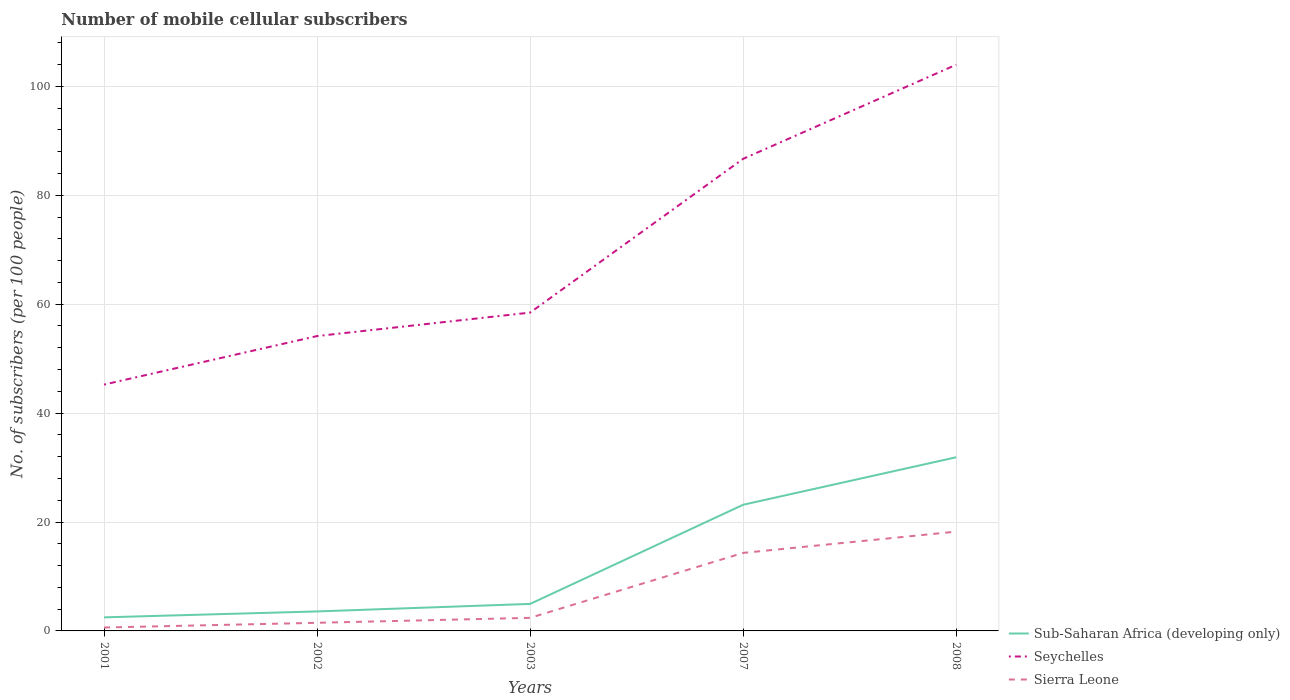How many different coloured lines are there?
Offer a very short reply. 3. Does the line corresponding to Sierra Leone intersect with the line corresponding to Sub-Saharan Africa (developing only)?
Your answer should be very brief. No. Is the number of lines equal to the number of legend labels?
Your answer should be compact. Yes. Across all years, what is the maximum number of mobile cellular subscribers in Sierra Leone?
Your response must be concise. 0.63. In which year was the number of mobile cellular subscribers in Sierra Leone maximum?
Your answer should be compact. 2001. What is the total number of mobile cellular subscribers in Sierra Leone in the graph?
Offer a terse response. -15.83. What is the difference between the highest and the second highest number of mobile cellular subscribers in Sierra Leone?
Provide a short and direct response. 17.61. What is the difference between the highest and the lowest number of mobile cellular subscribers in Seychelles?
Provide a short and direct response. 2. How many lines are there?
Your answer should be very brief. 3. Does the graph contain any zero values?
Provide a succinct answer. No. Does the graph contain grids?
Ensure brevity in your answer.  Yes. Where does the legend appear in the graph?
Offer a terse response. Bottom right. What is the title of the graph?
Keep it short and to the point. Number of mobile cellular subscribers. What is the label or title of the X-axis?
Give a very brief answer. Years. What is the label or title of the Y-axis?
Your answer should be very brief. No. of subscribers (per 100 people). What is the No. of subscribers (per 100 people) in Sub-Saharan Africa (developing only) in 2001?
Make the answer very short. 2.49. What is the No. of subscribers (per 100 people) in Seychelles in 2001?
Provide a succinct answer. 45.24. What is the No. of subscribers (per 100 people) in Sierra Leone in 2001?
Keep it short and to the point. 0.63. What is the No. of subscribers (per 100 people) of Sub-Saharan Africa (developing only) in 2002?
Provide a short and direct response. 3.58. What is the No. of subscribers (per 100 people) in Seychelles in 2002?
Give a very brief answer. 54.15. What is the No. of subscribers (per 100 people) of Sierra Leone in 2002?
Your answer should be compact. 1.49. What is the No. of subscribers (per 100 people) of Sub-Saharan Africa (developing only) in 2003?
Offer a terse response. 4.96. What is the No. of subscribers (per 100 people) of Seychelles in 2003?
Your response must be concise. 58.45. What is the No. of subscribers (per 100 people) of Sierra Leone in 2003?
Offer a very short reply. 2.4. What is the No. of subscribers (per 100 people) of Sub-Saharan Africa (developing only) in 2007?
Your answer should be compact. 23.17. What is the No. of subscribers (per 100 people) of Seychelles in 2007?
Your response must be concise. 86.7. What is the No. of subscribers (per 100 people) in Sierra Leone in 2007?
Keep it short and to the point. 14.33. What is the No. of subscribers (per 100 people) in Sub-Saharan Africa (developing only) in 2008?
Provide a succinct answer. 31.89. What is the No. of subscribers (per 100 people) of Seychelles in 2008?
Ensure brevity in your answer.  103.98. What is the No. of subscribers (per 100 people) of Sierra Leone in 2008?
Your answer should be very brief. 18.24. Across all years, what is the maximum No. of subscribers (per 100 people) of Sub-Saharan Africa (developing only)?
Provide a succinct answer. 31.89. Across all years, what is the maximum No. of subscribers (per 100 people) in Seychelles?
Provide a succinct answer. 103.98. Across all years, what is the maximum No. of subscribers (per 100 people) of Sierra Leone?
Your response must be concise. 18.24. Across all years, what is the minimum No. of subscribers (per 100 people) in Sub-Saharan Africa (developing only)?
Keep it short and to the point. 2.49. Across all years, what is the minimum No. of subscribers (per 100 people) of Seychelles?
Provide a succinct answer. 45.24. Across all years, what is the minimum No. of subscribers (per 100 people) of Sierra Leone?
Offer a terse response. 0.63. What is the total No. of subscribers (per 100 people) in Sub-Saharan Africa (developing only) in the graph?
Offer a terse response. 66.09. What is the total No. of subscribers (per 100 people) in Seychelles in the graph?
Your answer should be very brief. 348.51. What is the total No. of subscribers (per 100 people) in Sierra Leone in the graph?
Ensure brevity in your answer.  37.08. What is the difference between the No. of subscribers (per 100 people) of Sub-Saharan Africa (developing only) in 2001 and that in 2002?
Offer a very short reply. -1.08. What is the difference between the No. of subscribers (per 100 people) in Seychelles in 2001 and that in 2002?
Make the answer very short. -8.91. What is the difference between the No. of subscribers (per 100 people) in Sierra Leone in 2001 and that in 2002?
Your answer should be compact. -0.87. What is the difference between the No. of subscribers (per 100 people) in Sub-Saharan Africa (developing only) in 2001 and that in 2003?
Ensure brevity in your answer.  -2.47. What is the difference between the No. of subscribers (per 100 people) of Seychelles in 2001 and that in 2003?
Provide a short and direct response. -13.22. What is the difference between the No. of subscribers (per 100 people) of Sierra Leone in 2001 and that in 2003?
Make the answer very short. -1.78. What is the difference between the No. of subscribers (per 100 people) of Sub-Saharan Africa (developing only) in 2001 and that in 2007?
Your answer should be very brief. -20.68. What is the difference between the No. of subscribers (per 100 people) in Seychelles in 2001 and that in 2007?
Offer a terse response. -41.46. What is the difference between the No. of subscribers (per 100 people) in Sierra Leone in 2001 and that in 2007?
Give a very brief answer. -13.7. What is the difference between the No. of subscribers (per 100 people) of Sub-Saharan Africa (developing only) in 2001 and that in 2008?
Keep it short and to the point. -29.4. What is the difference between the No. of subscribers (per 100 people) in Seychelles in 2001 and that in 2008?
Your response must be concise. -58.74. What is the difference between the No. of subscribers (per 100 people) in Sierra Leone in 2001 and that in 2008?
Keep it short and to the point. -17.61. What is the difference between the No. of subscribers (per 100 people) in Sub-Saharan Africa (developing only) in 2002 and that in 2003?
Ensure brevity in your answer.  -1.38. What is the difference between the No. of subscribers (per 100 people) in Seychelles in 2002 and that in 2003?
Make the answer very short. -4.31. What is the difference between the No. of subscribers (per 100 people) of Sierra Leone in 2002 and that in 2003?
Your answer should be very brief. -0.91. What is the difference between the No. of subscribers (per 100 people) of Sub-Saharan Africa (developing only) in 2002 and that in 2007?
Offer a terse response. -19.59. What is the difference between the No. of subscribers (per 100 people) of Seychelles in 2002 and that in 2007?
Offer a terse response. -32.55. What is the difference between the No. of subscribers (per 100 people) of Sierra Leone in 2002 and that in 2007?
Give a very brief answer. -12.84. What is the difference between the No. of subscribers (per 100 people) in Sub-Saharan Africa (developing only) in 2002 and that in 2008?
Provide a succinct answer. -28.31. What is the difference between the No. of subscribers (per 100 people) in Seychelles in 2002 and that in 2008?
Keep it short and to the point. -49.83. What is the difference between the No. of subscribers (per 100 people) of Sierra Leone in 2002 and that in 2008?
Keep it short and to the point. -16.74. What is the difference between the No. of subscribers (per 100 people) in Sub-Saharan Africa (developing only) in 2003 and that in 2007?
Give a very brief answer. -18.21. What is the difference between the No. of subscribers (per 100 people) of Seychelles in 2003 and that in 2007?
Make the answer very short. -28.24. What is the difference between the No. of subscribers (per 100 people) of Sierra Leone in 2003 and that in 2007?
Offer a terse response. -11.93. What is the difference between the No. of subscribers (per 100 people) in Sub-Saharan Africa (developing only) in 2003 and that in 2008?
Provide a short and direct response. -26.93. What is the difference between the No. of subscribers (per 100 people) of Seychelles in 2003 and that in 2008?
Your answer should be very brief. -45.52. What is the difference between the No. of subscribers (per 100 people) of Sierra Leone in 2003 and that in 2008?
Your answer should be compact. -15.83. What is the difference between the No. of subscribers (per 100 people) of Sub-Saharan Africa (developing only) in 2007 and that in 2008?
Give a very brief answer. -8.72. What is the difference between the No. of subscribers (per 100 people) in Seychelles in 2007 and that in 2008?
Your answer should be very brief. -17.28. What is the difference between the No. of subscribers (per 100 people) in Sierra Leone in 2007 and that in 2008?
Your response must be concise. -3.91. What is the difference between the No. of subscribers (per 100 people) of Sub-Saharan Africa (developing only) in 2001 and the No. of subscribers (per 100 people) of Seychelles in 2002?
Provide a succinct answer. -51.65. What is the difference between the No. of subscribers (per 100 people) of Seychelles in 2001 and the No. of subscribers (per 100 people) of Sierra Leone in 2002?
Ensure brevity in your answer.  43.74. What is the difference between the No. of subscribers (per 100 people) of Sub-Saharan Africa (developing only) in 2001 and the No. of subscribers (per 100 people) of Seychelles in 2003?
Your response must be concise. -55.96. What is the difference between the No. of subscribers (per 100 people) in Sub-Saharan Africa (developing only) in 2001 and the No. of subscribers (per 100 people) in Sierra Leone in 2003?
Ensure brevity in your answer.  0.09. What is the difference between the No. of subscribers (per 100 people) in Seychelles in 2001 and the No. of subscribers (per 100 people) in Sierra Leone in 2003?
Your response must be concise. 42.83. What is the difference between the No. of subscribers (per 100 people) of Sub-Saharan Africa (developing only) in 2001 and the No. of subscribers (per 100 people) of Seychelles in 2007?
Give a very brief answer. -84.21. What is the difference between the No. of subscribers (per 100 people) of Sub-Saharan Africa (developing only) in 2001 and the No. of subscribers (per 100 people) of Sierra Leone in 2007?
Offer a very short reply. -11.83. What is the difference between the No. of subscribers (per 100 people) of Seychelles in 2001 and the No. of subscribers (per 100 people) of Sierra Leone in 2007?
Offer a very short reply. 30.91. What is the difference between the No. of subscribers (per 100 people) of Sub-Saharan Africa (developing only) in 2001 and the No. of subscribers (per 100 people) of Seychelles in 2008?
Ensure brevity in your answer.  -101.48. What is the difference between the No. of subscribers (per 100 people) in Sub-Saharan Africa (developing only) in 2001 and the No. of subscribers (per 100 people) in Sierra Leone in 2008?
Keep it short and to the point. -15.74. What is the difference between the No. of subscribers (per 100 people) in Seychelles in 2001 and the No. of subscribers (per 100 people) in Sierra Leone in 2008?
Provide a short and direct response. 27. What is the difference between the No. of subscribers (per 100 people) in Sub-Saharan Africa (developing only) in 2002 and the No. of subscribers (per 100 people) in Seychelles in 2003?
Provide a short and direct response. -54.88. What is the difference between the No. of subscribers (per 100 people) in Sub-Saharan Africa (developing only) in 2002 and the No. of subscribers (per 100 people) in Sierra Leone in 2003?
Your response must be concise. 1.18. What is the difference between the No. of subscribers (per 100 people) of Seychelles in 2002 and the No. of subscribers (per 100 people) of Sierra Leone in 2003?
Offer a terse response. 51.74. What is the difference between the No. of subscribers (per 100 people) in Sub-Saharan Africa (developing only) in 2002 and the No. of subscribers (per 100 people) in Seychelles in 2007?
Your response must be concise. -83.12. What is the difference between the No. of subscribers (per 100 people) of Sub-Saharan Africa (developing only) in 2002 and the No. of subscribers (per 100 people) of Sierra Leone in 2007?
Provide a succinct answer. -10.75. What is the difference between the No. of subscribers (per 100 people) of Seychelles in 2002 and the No. of subscribers (per 100 people) of Sierra Leone in 2007?
Offer a very short reply. 39.82. What is the difference between the No. of subscribers (per 100 people) of Sub-Saharan Africa (developing only) in 2002 and the No. of subscribers (per 100 people) of Seychelles in 2008?
Keep it short and to the point. -100.4. What is the difference between the No. of subscribers (per 100 people) of Sub-Saharan Africa (developing only) in 2002 and the No. of subscribers (per 100 people) of Sierra Leone in 2008?
Ensure brevity in your answer.  -14.66. What is the difference between the No. of subscribers (per 100 people) of Seychelles in 2002 and the No. of subscribers (per 100 people) of Sierra Leone in 2008?
Your answer should be compact. 35.91. What is the difference between the No. of subscribers (per 100 people) in Sub-Saharan Africa (developing only) in 2003 and the No. of subscribers (per 100 people) in Seychelles in 2007?
Keep it short and to the point. -81.74. What is the difference between the No. of subscribers (per 100 people) of Sub-Saharan Africa (developing only) in 2003 and the No. of subscribers (per 100 people) of Sierra Leone in 2007?
Provide a short and direct response. -9.37. What is the difference between the No. of subscribers (per 100 people) of Seychelles in 2003 and the No. of subscribers (per 100 people) of Sierra Leone in 2007?
Make the answer very short. 44.13. What is the difference between the No. of subscribers (per 100 people) in Sub-Saharan Africa (developing only) in 2003 and the No. of subscribers (per 100 people) in Seychelles in 2008?
Keep it short and to the point. -99.02. What is the difference between the No. of subscribers (per 100 people) of Sub-Saharan Africa (developing only) in 2003 and the No. of subscribers (per 100 people) of Sierra Leone in 2008?
Offer a very short reply. -13.28. What is the difference between the No. of subscribers (per 100 people) in Seychelles in 2003 and the No. of subscribers (per 100 people) in Sierra Leone in 2008?
Provide a short and direct response. 40.22. What is the difference between the No. of subscribers (per 100 people) in Sub-Saharan Africa (developing only) in 2007 and the No. of subscribers (per 100 people) in Seychelles in 2008?
Give a very brief answer. -80.81. What is the difference between the No. of subscribers (per 100 people) in Sub-Saharan Africa (developing only) in 2007 and the No. of subscribers (per 100 people) in Sierra Leone in 2008?
Provide a short and direct response. 4.94. What is the difference between the No. of subscribers (per 100 people) in Seychelles in 2007 and the No. of subscribers (per 100 people) in Sierra Leone in 2008?
Your response must be concise. 68.46. What is the average No. of subscribers (per 100 people) of Sub-Saharan Africa (developing only) per year?
Your response must be concise. 13.22. What is the average No. of subscribers (per 100 people) in Seychelles per year?
Provide a succinct answer. 69.7. What is the average No. of subscribers (per 100 people) of Sierra Leone per year?
Provide a succinct answer. 7.42. In the year 2001, what is the difference between the No. of subscribers (per 100 people) in Sub-Saharan Africa (developing only) and No. of subscribers (per 100 people) in Seychelles?
Make the answer very short. -42.74. In the year 2001, what is the difference between the No. of subscribers (per 100 people) in Sub-Saharan Africa (developing only) and No. of subscribers (per 100 people) in Sierra Leone?
Provide a short and direct response. 1.87. In the year 2001, what is the difference between the No. of subscribers (per 100 people) in Seychelles and No. of subscribers (per 100 people) in Sierra Leone?
Your answer should be compact. 44.61. In the year 2002, what is the difference between the No. of subscribers (per 100 people) of Sub-Saharan Africa (developing only) and No. of subscribers (per 100 people) of Seychelles?
Your answer should be compact. -50.57. In the year 2002, what is the difference between the No. of subscribers (per 100 people) of Sub-Saharan Africa (developing only) and No. of subscribers (per 100 people) of Sierra Leone?
Provide a succinct answer. 2.09. In the year 2002, what is the difference between the No. of subscribers (per 100 people) of Seychelles and No. of subscribers (per 100 people) of Sierra Leone?
Offer a terse response. 52.66. In the year 2003, what is the difference between the No. of subscribers (per 100 people) of Sub-Saharan Africa (developing only) and No. of subscribers (per 100 people) of Seychelles?
Ensure brevity in your answer.  -53.49. In the year 2003, what is the difference between the No. of subscribers (per 100 people) in Sub-Saharan Africa (developing only) and No. of subscribers (per 100 people) in Sierra Leone?
Ensure brevity in your answer.  2.56. In the year 2003, what is the difference between the No. of subscribers (per 100 people) in Seychelles and No. of subscribers (per 100 people) in Sierra Leone?
Your answer should be compact. 56.05. In the year 2007, what is the difference between the No. of subscribers (per 100 people) in Sub-Saharan Africa (developing only) and No. of subscribers (per 100 people) in Seychelles?
Give a very brief answer. -63.53. In the year 2007, what is the difference between the No. of subscribers (per 100 people) of Sub-Saharan Africa (developing only) and No. of subscribers (per 100 people) of Sierra Leone?
Your response must be concise. 8.84. In the year 2007, what is the difference between the No. of subscribers (per 100 people) in Seychelles and No. of subscribers (per 100 people) in Sierra Leone?
Provide a succinct answer. 72.37. In the year 2008, what is the difference between the No. of subscribers (per 100 people) in Sub-Saharan Africa (developing only) and No. of subscribers (per 100 people) in Seychelles?
Your answer should be very brief. -72.09. In the year 2008, what is the difference between the No. of subscribers (per 100 people) of Sub-Saharan Africa (developing only) and No. of subscribers (per 100 people) of Sierra Leone?
Provide a succinct answer. 13.65. In the year 2008, what is the difference between the No. of subscribers (per 100 people) of Seychelles and No. of subscribers (per 100 people) of Sierra Leone?
Provide a short and direct response. 85.74. What is the ratio of the No. of subscribers (per 100 people) in Sub-Saharan Africa (developing only) in 2001 to that in 2002?
Provide a succinct answer. 0.7. What is the ratio of the No. of subscribers (per 100 people) in Seychelles in 2001 to that in 2002?
Make the answer very short. 0.84. What is the ratio of the No. of subscribers (per 100 people) in Sierra Leone in 2001 to that in 2002?
Your answer should be very brief. 0.42. What is the ratio of the No. of subscribers (per 100 people) in Sub-Saharan Africa (developing only) in 2001 to that in 2003?
Your answer should be very brief. 0.5. What is the ratio of the No. of subscribers (per 100 people) in Seychelles in 2001 to that in 2003?
Give a very brief answer. 0.77. What is the ratio of the No. of subscribers (per 100 people) in Sierra Leone in 2001 to that in 2003?
Ensure brevity in your answer.  0.26. What is the ratio of the No. of subscribers (per 100 people) of Sub-Saharan Africa (developing only) in 2001 to that in 2007?
Make the answer very short. 0.11. What is the ratio of the No. of subscribers (per 100 people) in Seychelles in 2001 to that in 2007?
Offer a very short reply. 0.52. What is the ratio of the No. of subscribers (per 100 people) in Sierra Leone in 2001 to that in 2007?
Give a very brief answer. 0.04. What is the ratio of the No. of subscribers (per 100 people) in Sub-Saharan Africa (developing only) in 2001 to that in 2008?
Your answer should be compact. 0.08. What is the ratio of the No. of subscribers (per 100 people) of Seychelles in 2001 to that in 2008?
Your response must be concise. 0.44. What is the ratio of the No. of subscribers (per 100 people) of Sierra Leone in 2001 to that in 2008?
Your answer should be compact. 0.03. What is the ratio of the No. of subscribers (per 100 people) of Sub-Saharan Africa (developing only) in 2002 to that in 2003?
Offer a terse response. 0.72. What is the ratio of the No. of subscribers (per 100 people) of Seychelles in 2002 to that in 2003?
Offer a terse response. 0.93. What is the ratio of the No. of subscribers (per 100 people) of Sierra Leone in 2002 to that in 2003?
Your response must be concise. 0.62. What is the ratio of the No. of subscribers (per 100 people) of Sub-Saharan Africa (developing only) in 2002 to that in 2007?
Provide a succinct answer. 0.15. What is the ratio of the No. of subscribers (per 100 people) in Seychelles in 2002 to that in 2007?
Keep it short and to the point. 0.62. What is the ratio of the No. of subscribers (per 100 people) in Sierra Leone in 2002 to that in 2007?
Provide a succinct answer. 0.1. What is the ratio of the No. of subscribers (per 100 people) of Sub-Saharan Africa (developing only) in 2002 to that in 2008?
Make the answer very short. 0.11. What is the ratio of the No. of subscribers (per 100 people) of Seychelles in 2002 to that in 2008?
Provide a short and direct response. 0.52. What is the ratio of the No. of subscribers (per 100 people) in Sierra Leone in 2002 to that in 2008?
Offer a very short reply. 0.08. What is the ratio of the No. of subscribers (per 100 people) in Sub-Saharan Africa (developing only) in 2003 to that in 2007?
Offer a terse response. 0.21. What is the ratio of the No. of subscribers (per 100 people) of Seychelles in 2003 to that in 2007?
Your response must be concise. 0.67. What is the ratio of the No. of subscribers (per 100 people) in Sierra Leone in 2003 to that in 2007?
Provide a succinct answer. 0.17. What is the ratio of the No. of subscribers (per 100 people) in Sub-Saharan Africa (developing only) in 2003 to that in 2008?
Your answer should be very brief. 0.16. What is the ratio of the No. of subscribers (per 100 people) in Seychelles in 2003 to that in 2008?
Provide a short and direct response. 0.56. What is the ratio of the No. of subscribers (per 100 people) in Sierra Leone in 2003 to that in 2008?
Give a very brief answer. 0.13. What is the ratio of the No. of subscribers (per 100 people) in Sub-Saharan Africa (developing only) in 2007 to that in 2008?
Ensure brevity in your answer.  0.73. What is the ratio of the No. of subscribers (per 100 people) of Seychelles in 2007 to that in 2008?
Your answer should be compact. 0.83. What is the ratio of the No. of subscribers (per 100 people) in Sierra Leone in 2007 to that in 2008?
Offer a very short reply. 0.79. What is the difference between the highest and the second highest No. of subscribers (per 100 people) in Sub-Saharan Africa (developing only)?
Provide a succinct answer. 8.72. What is the difference between the highest and the second highest No. of subscribers (per 100 people) of Seychelles?
Your response must be concise. 17.28. What is the difference between the highest and the second highest No. of subscribers (per 100 people) in Sierra Leone?
Your response must be concise. 3.91. What is the difference between the highest and the lowest No. of subscribers (per 100 people) in Sub-Saharan Africa (developing only)?
Provide a succinct answer. 29.4. What is the difference between the highest and the lowest No. of subscribers (per 100 people) in Seychelles?
Your answer should be compact. 58.74. What is the difference between the highest and the lowest No. of subscribers (per 100 people) of Sierra Leone?
Make the answer very short. 17.61. 